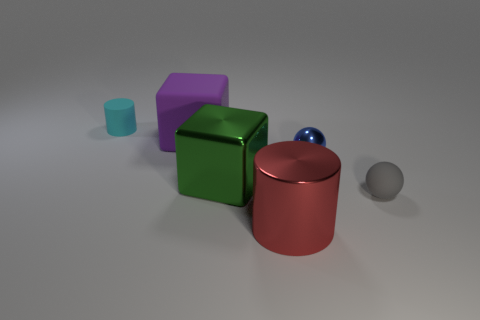Add 2 small matte cylinders. How many objects exist? 8 Subtract all cubes. How many objects are left? 4 Add 4 big gray shiny spheres. How many big gray shiny spheres exist? 4 Subtract 0 red balls. How many objects are left? 6 Subtract all blue balls. Subtract all blue cubes. How many balls are left? 1 Subtract all tiny blue metal balls. Subtract all small gray spheres. How many objects are left? 4 Add 6 purple things. How many purple things are left? 7 